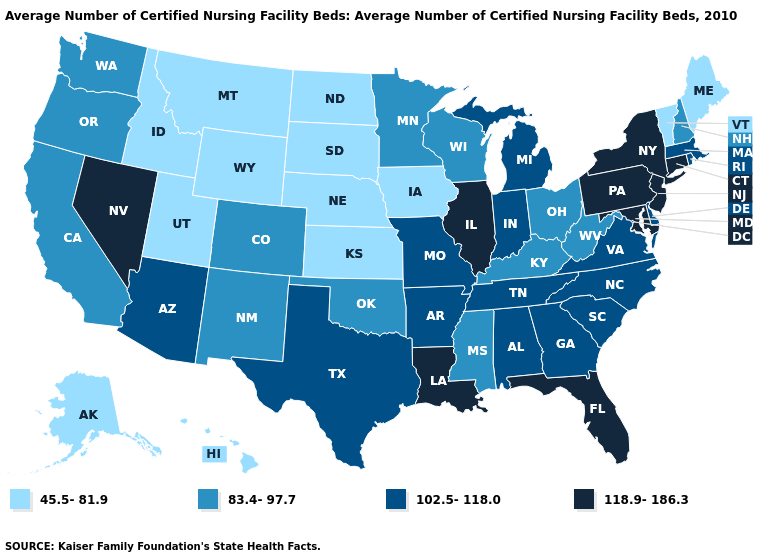Name the states that have a value in the range 45.5-81.9?
Short answer required. Alaska, Hawaii, Idaho, Iowa, Kansas, Maine, Montana, Nebraska, North Dakota, South Dakota, Utah, Vermont, Wyoming. Name the states that have a value in the range 118.9-186.3?
Keep it brief. Connecticut, Florida, Illinois, Louisiana, Maryland, Nevada, New Jersey, New York, Pennsylvania. Which states have the lowest value in the South?
Short answer required. Kentucky, Mississippi, Oklahoma, West Virginia. Among the states that border Delaware , which have the lowest value?
Concise answer only. Maryland, New Jersey, Pennsylvania. What is the value of Rhode Island?
Be succinct. 102.5-118.0. What is the lowest value in the West?
Answer briefly. 45.5-81.9. What is the value of Minnesota?
Give a very brief answer. 83.4-97.7. What is the value of Louisiana?
Write a very short answer. 118.9-186.3. What is the value of Wisconsin?
Concise answer only. 83.4-97.7. What is the lowest value in the West?
Concise answer only. 45.5-81.9. Name the states that have a value in the range 102.5-118.0?
Short answer required. Alabama, Arizona, Arkansas, Delaware, Georgia, Indiana, Massachusetts, Michigan, Missouri, North Carolina, Rhode Island, South Carolina, Tennessee, Texas, Virginia. Among the states that border California , does Nevada have the lowest value?
Quick response, please. No. Name the states that have a value in the range 83.4-97.7?
Be succinct. California, Colorado, Kentucky, Minnesota, Mississippi, New Hampshire, New Mexico, Ohio, Oklahoma, Oregon, Washington, West Virginia, Wisconsin. How many symbols are there in the legend?
Write a very short answer. 4. Does Illinois have the highest value in the MidWest?
Quick response, please. Yes. 